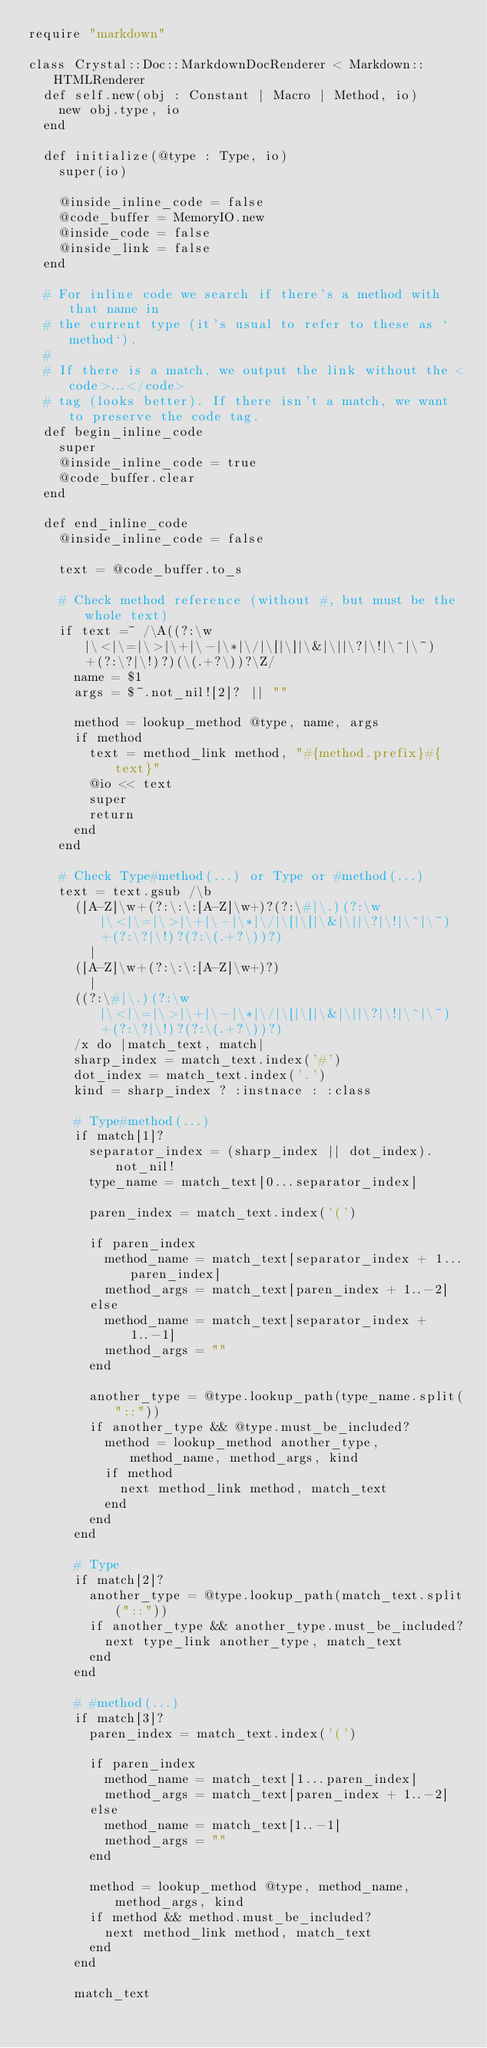<code> <loc_0><loc_0><loc_500><loc_500><_Crystal_>require "markdown"

class Crystal::Doc::MarkdownDocRenderer < Markdown::HTMLRenderer
  def self.new(obj : Constant | Macro | Method, io)
    new obj.type, io
  end

  def initialize(@type : Type, io)
    super(io)

    @inside_inline_code = false
    @code_buffer = MemoryIO.new
    @inside_code = false
    @inside_link = false
  end

  # For inline code we search if there's a method with that name in
  # the current type (it's usual to refer to these as `method`).
  #
  # If there is a match, we output the link without the <code>...</code>
  # tag (looks better). If there isn't a match, we want to preserve the code tag.
  def begin_inline_code
    super
    @inside_inline_code = true
    @code_buffer.clear
  end

  def end_inline_code
    @inside_inline_code = false

    text = @code_buffer.to_s

    # Check method reference (without #, but must be the whole text)
    if text =~ /\A((?:\w|\<|\=|\>|\+|\-|\*|\/|\[|\]|\&|\||\?|\!|\^|\~)+(?:\?|\!)?)(\(.+?\))?\Z/
      name = $1
      args = $~.not_nil![2]? || ""

      method = lookup_method @type, name, args
      if method
        text = method_link method, "#{method.prefix}#{text}"
        @io << text
        super
        return
      end
    end

    # Check Type#method(...) or Type or #method(...)
    text = text.gsub /\b
      ([A-Z]\w+(?:\:\:[A-Z]\w+)?(?:\#|\.)(?:\w|\<|\=|\>|\+|\-|\*|\/|\[|\]|\&|\||\?|\!|\^|\~)+(?:\?|\!)?(?:\(.+?\))?)
        |
      ([A-Z]\w+(?:\:\:[A-Z]\w+)?)
        |
      ((?:\#|\.)(?:\w|\<|\=|\>|\+|\-|\*|\/|\[|\]|\&|\||\?|\!|\^|\~)+(?:\?|\!)?(?:\(.+?\))?)
      /x do |match_text, match|
      sharp_index = match_text.index('#')
      dot_index = match_text.index('.')
      kind = sharp_index ? :instnace : :class

      # Type#method(...)
      if match[1]?
        separator_index = (sharp_index || dot_index).not_nil!
        type_name = match_text[0...separator_index]

        paren_index = match_text.index('(')

        if paren_index
          method_name = match_text[separator_index + 1...paren_index]
          method_args = match_text[paren_index + 1..-2]
        else
          method_name = match_text[separator_index + 1..-1]
          method_args = ""
        end

        another_type = @type.lookup_path(type_name.split("::"))
        if another_type && @type.must_be_included?
          method = lookup_method another_type, method_name, method_args, kind
          if method
            next method_link method, match_text
          end
        end
      end

      # Type
      if match[2]?
        another_type = @type.lookup_path(match_text.split("::"))
        if another_type && another_type.must_be_included?
          next type_link another_type, match_text
        end
      end

      # #method(...)
      if match[3]?
        paren_index = match_text.index('(')

        if paren_index
          method_name = match_text[1...paren_index]
          method_args = match_text[paren_index + 1..-2]
        else
          method_name = match_text[1..-1]
          method_args = ""
        end

        method = lookup_method @type, method_name, method_args, kind
        if method && method.must_be_included?
          next method_link method, match_text
        end
      end

      match_text</code> 